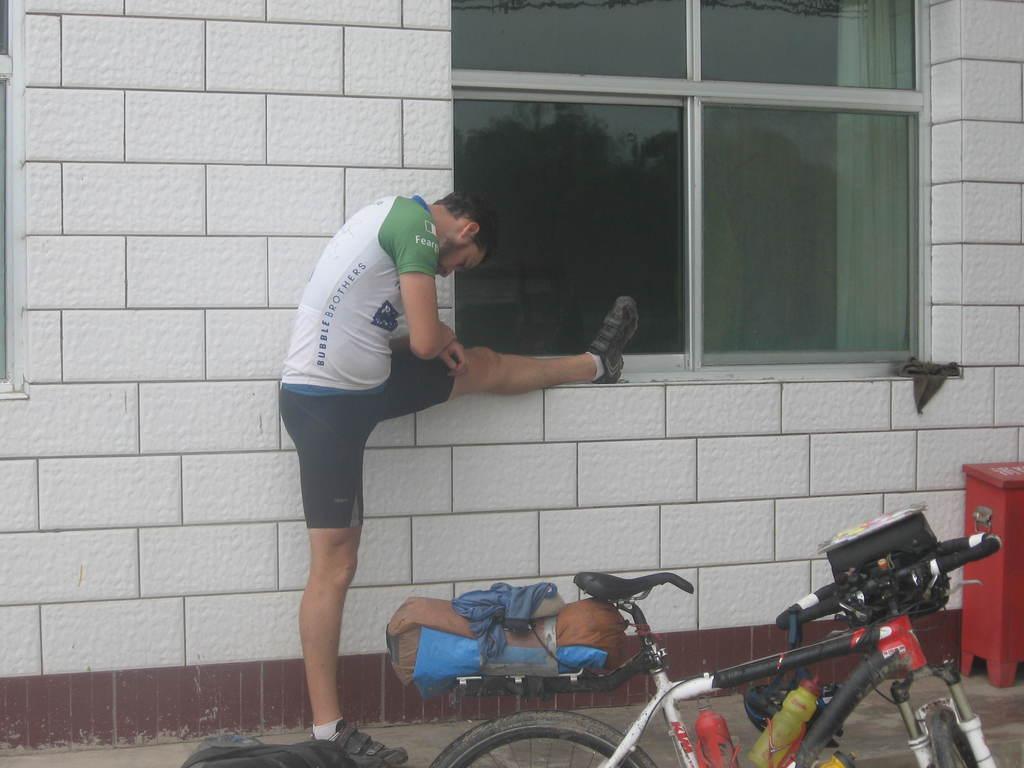Describe this image in one or two sentences. In this image I can see a bicycle. I can see two bottles. I can see a person. In the background, I can see the wall and the window. 